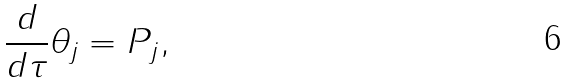Convert formula to latex. <formula><loc_0><loc_0><loc_500><loc_500>\frac { d } { d \tau } \theta _ { j } = P _ { j } ,</formula> 